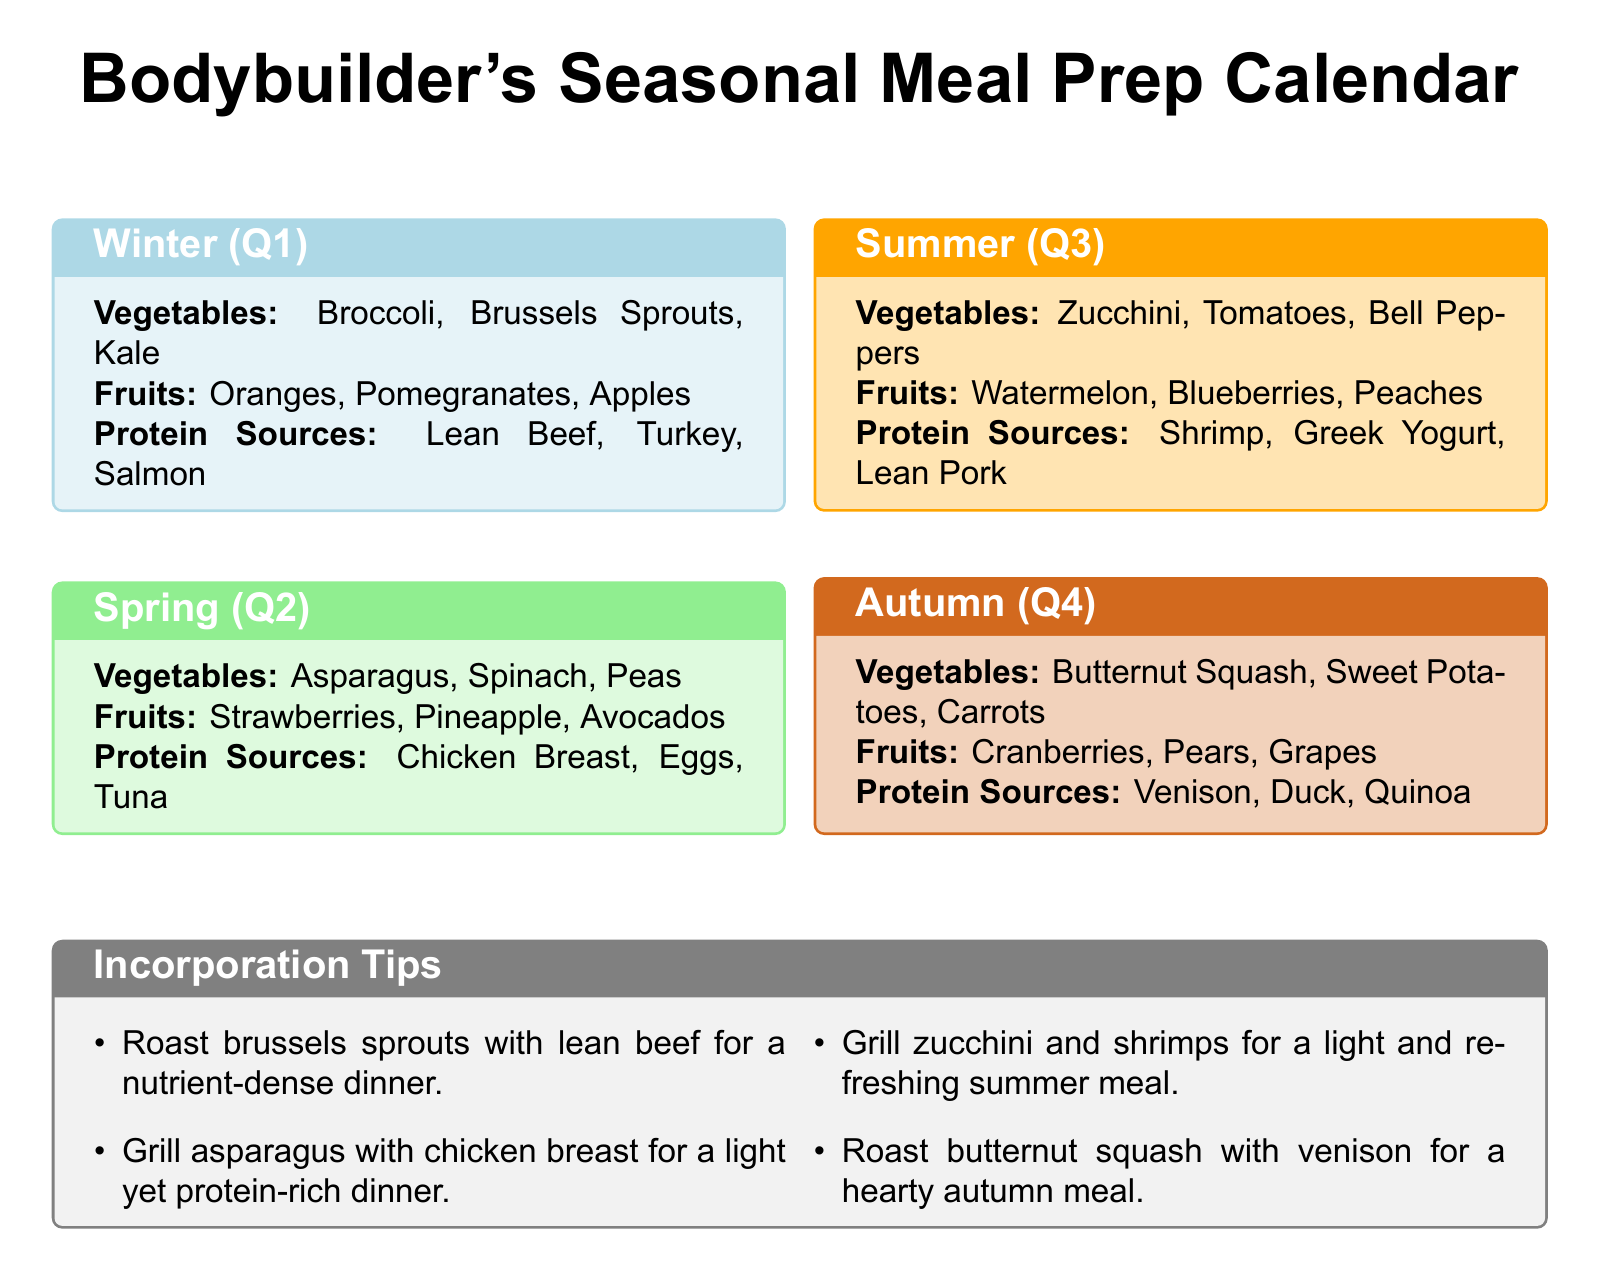What vegetables are in season during winter? The vegetables listed for winter are broccoli, Brussels sprouts, and kale.
Answer: Broccoli, Brussels Sprouts, Kale What fruits are available in spring? The fruits listed for spring are strawberries, pineapple, and avocados.
Answer: Strawberries, Pineapple, Avocados Which protein sources are mentioned for summer? The protein sources for summer include shrimp, Greek yogurt, and lean pork.
Answer: Shrimp, Greek Yogurt, Lean Pork What is a suggested meal using brussels sprouts? One suggestion is to roast brussels sprouts with lean beef.
Answer: Roast brussels sprouts with lean beef Which season features butternut squash? Butternut squash is featured in autumn.
Answer: Autumn How many protein sources are listed for the spring season? There are three protein sources listed for spring, which are chicken breast, eggs, and tuna.
Answer: Three What is a recommended preparation method for asparagus? The document suggests grilling asparagus with chicken breast.
Answer: Grill Which fruit is listed for summer? The fruits listed for summer include watermelon, blueberries, and peaches.
Answer: Watermelon, Blueberries, Peaches 